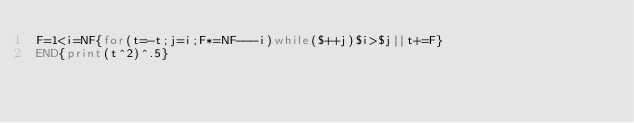Convert code to text. <code><loc_0><loc_0><loc_500><loc_500><_Awk_>F=1<i=NF{for(t=-t;j=i;F*=NF---i)while($++j)$i>$j||t+=F}
END{print(t^2)^.5}</code> 